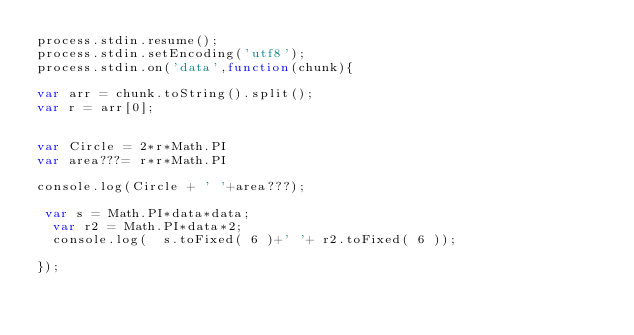Convert code to text. <code><loc_0><loc_0><loc_500><loc_500><_JavaScript_>process.stdin.resume();
process.stdin.setEncoding('utf8');
process.stdin.on('data',function(chunk){

var arr = chunk.toString().split();
var r = arr[0];


var Circle = 2*r*Math.PI
var area???= r*r*Math.PI

console.log(Circle + ' '+area???);

 var s = Math.PI*data*data;
  var r2 = Math.PI*data*2;
  console.log(  s.toFixed( 6 )+' '+ r2.toFixed( 6 ));

});</code> 